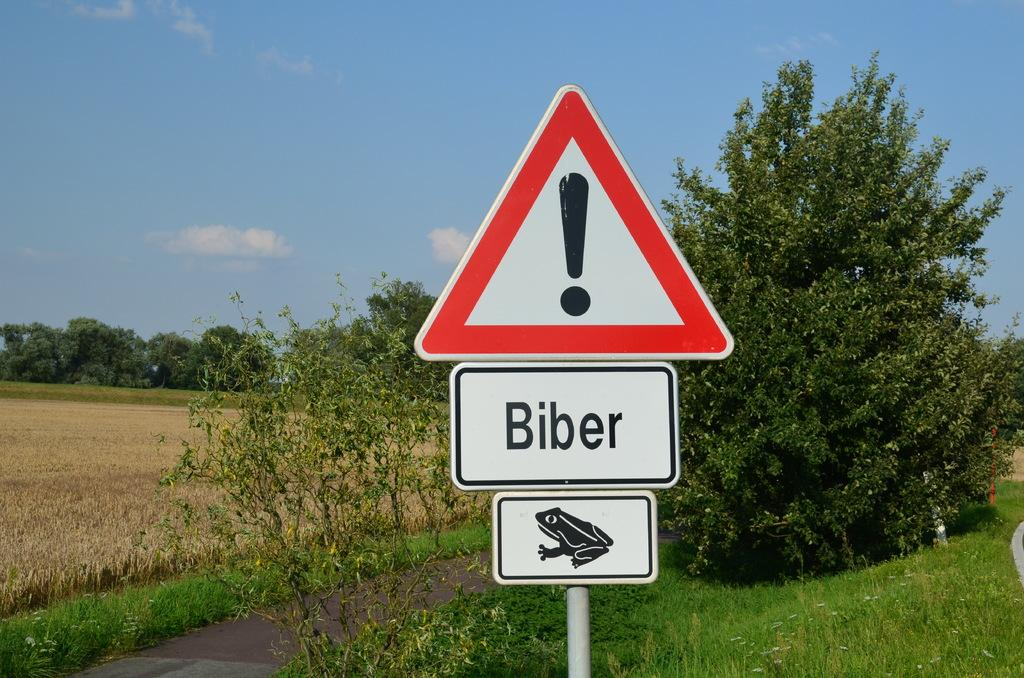<image>
Write a terse but informative summary of the picture. A warning sign with an exclamation mark tells you to watch out for Biber and frogs. 